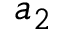<formula> <loc_0><loc_0><loc_500><loc_500>a _ { 2 }</formula> 